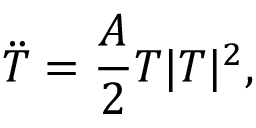Convert formula to latex. <formula><loc_0><loc_0><loc_500><loc_500>\ddot { T } = \frac { A } { 2 } T | T | ^ { 2 } ,</formula> 